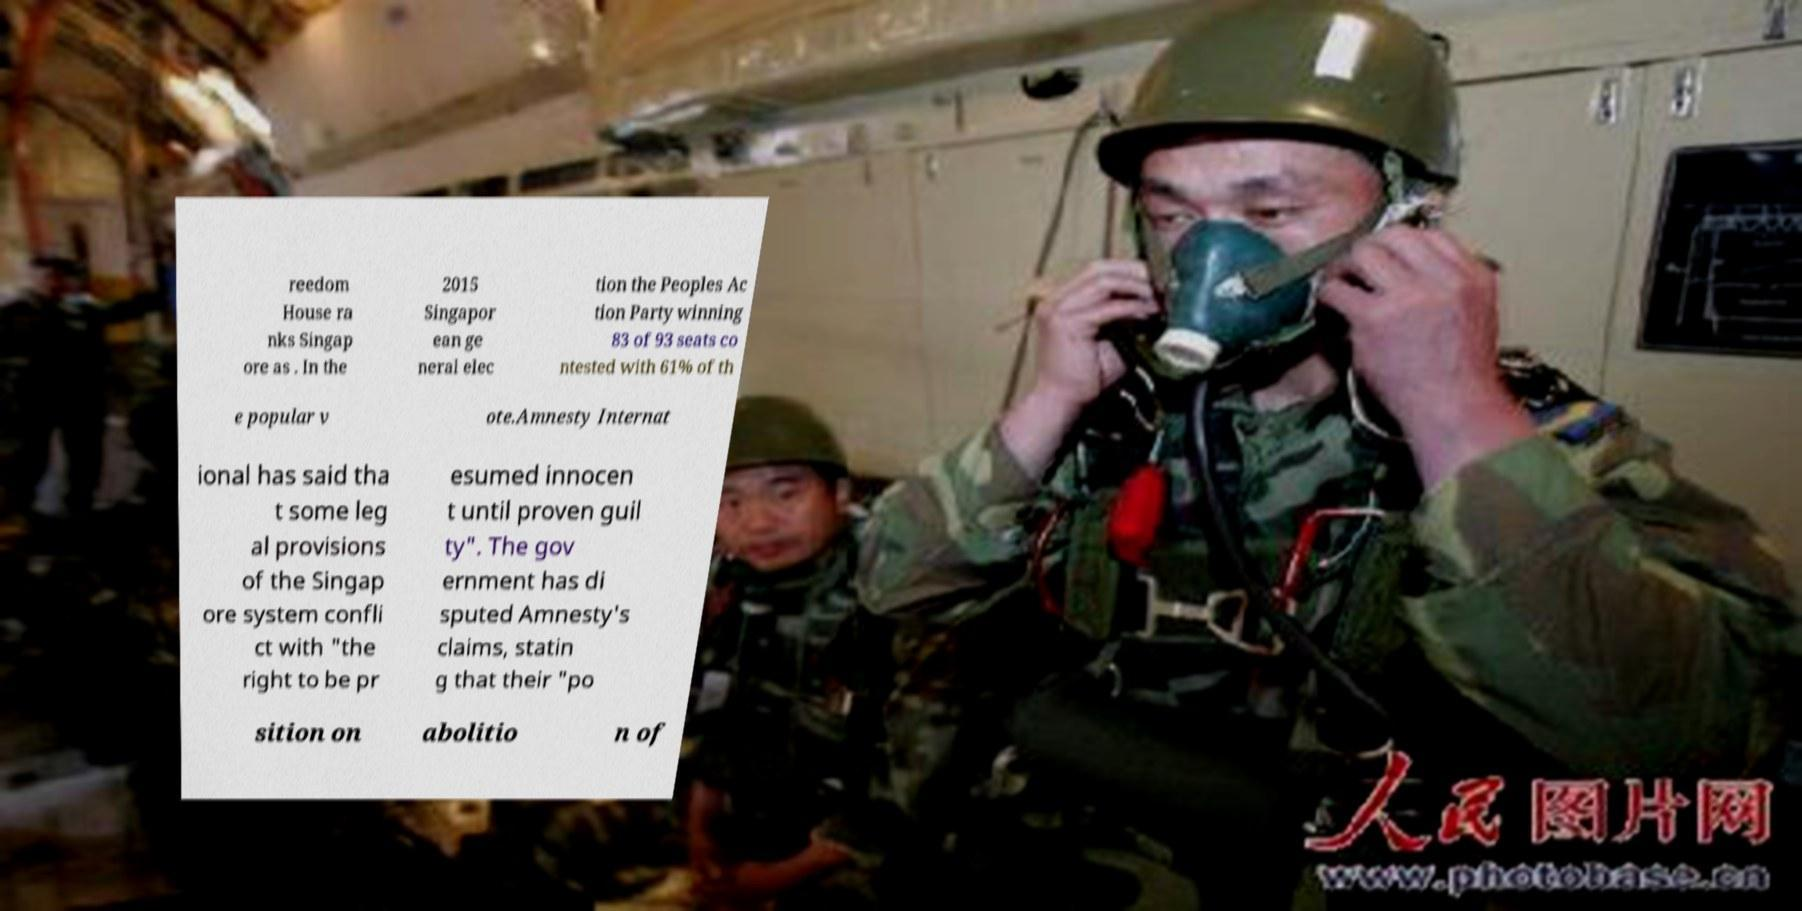There's text embedded in this image that I need extracted. Can you transcribe it verbatim? reedom House ra nks Singap ore as . In the 2015 Singapor ean ge neral elec tion the Peoples Ac tion Party winning 83 of 93 seats co ntested with 61% of th e popular v ote.Amnesty Internat ional has said tha t some leg al provisions of the Singap ore system confli ct with "the right to be pr esumed innocen t until proven guil ty". The gov ernment has di sputed Amnesty's claims, statin g that their "po sition on abolitio n of 